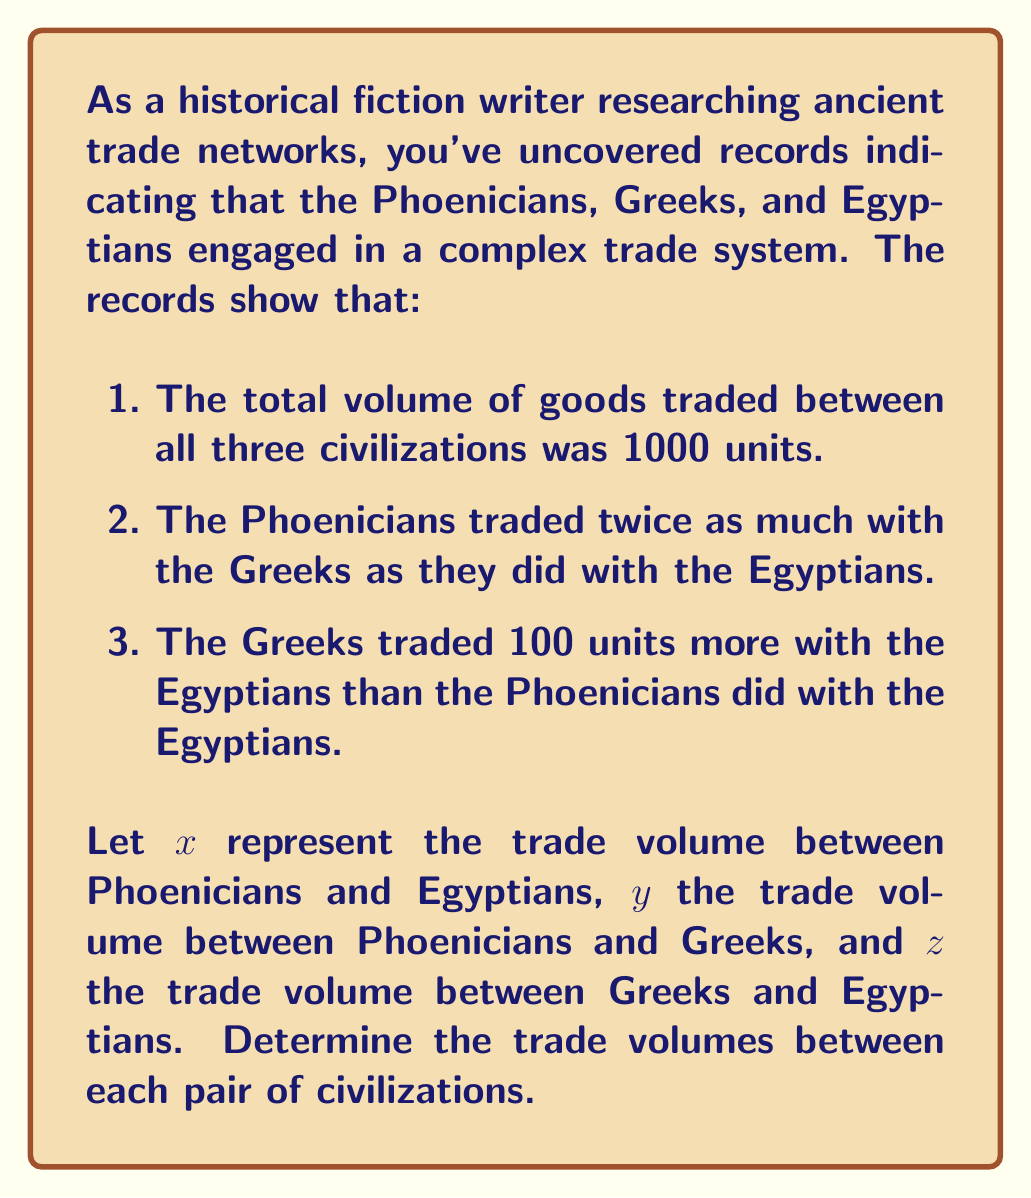Show me your answer to this math problem. Let's solve this problem step by step using a system of equations:

1. From the given information, we can set up three equations:

   Equation 1: $x + y + z = 1000$ (total trade volume)
   Equation 2: $y = 2x$ (Phoenicians traded twice as much with Greeks as with Egyptians)
   Equation 3: $z = x + 100$ (Greeks traded 100 units more with Egyptians than Phoenicians did)

2. Substitute Equation 2 and Equation 3 into Equation 1:

   $x + 2x + (x + 100) = 1000$

3. Simplify:

   $4x + 100 = 1000$

4. Solve for $x$:

   $4x = 900$
   $x = 225$

5. Now that we know $x$, we can find $y$ and $z$:

   $y = 2x = 2(225) = 450$
   $z = x + 100 = 225 + 100 = 325$

6. Verify the solution:

   $x + y + z = 225 + 450 + 325 = 1000$ (checks out)

Therefore, the trade volumes are:
- Phoenicians and Egyptians: 225 units
- Phoenicians and Greeks: 450 units
- Greeks and Egyptians: 325 units
Answer: Phoenicians-Egyptians: 225, Phoenicians-Greeks: 450, Greeks-Egyptians: 325 